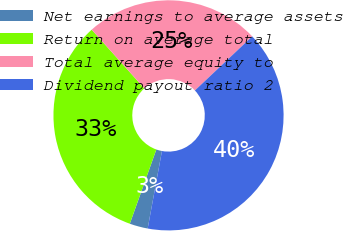<chart> <loc_0><loc_0><loc_500><loc_500><pie_chart><fcel>Net earnings to average assets<fcel>Return on average total<fcel>Total average equity to<fcel>Dividend payout ratio 2<nl><fcel>2.56%<fcel>32.91%<fcel>24.6%<fcel>39.94%<nl></chart> 